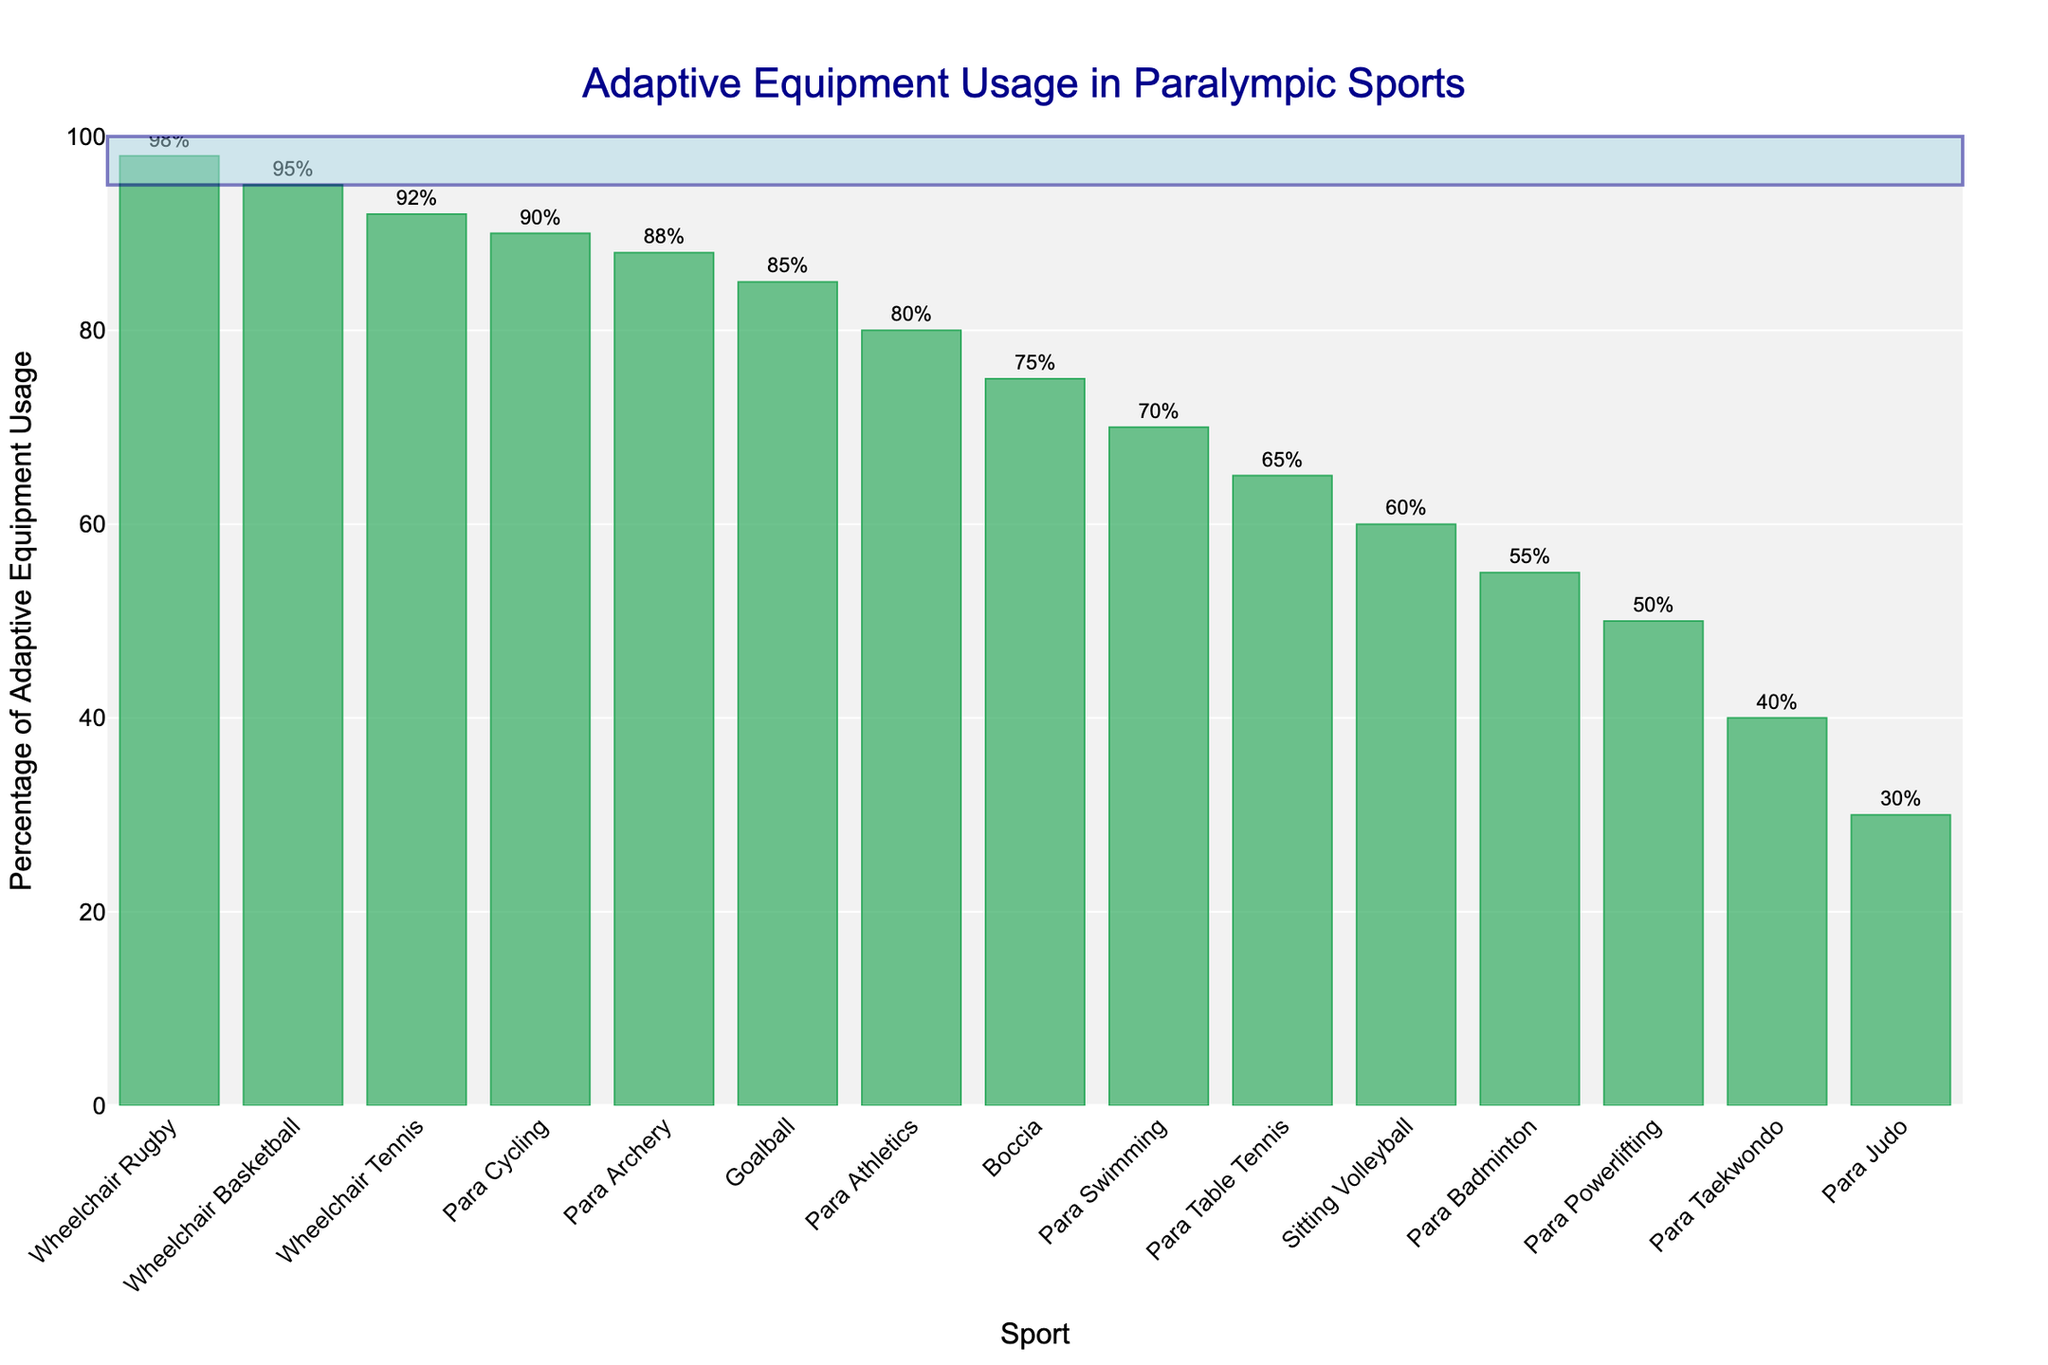Which sport has the highest percentage of adaptive equipment usage? To find the answer, look for the tallest bar in the chart. The title of the sport underneath this bar will indicate the sport with the highest usage.
Answer: Wheelchair Rugby Which sport has the lowest percentage of adaptive equipment usage? To determine this, identify the shortest bar in the chart and check the label of that sport.
Answer: Para Judo What is the difference in adaptive equipment usage between Para Judo and Wheelchair Rugby? First, note the percentage values for both sports from the corresponding bars. Then, subtract the percentage of Para Judo from that of Wheelchair Rugby (98% - 30%).
Answer: 68% Which sport has a higher percentage of adaptive equipment usage: Para Archery or Para Swimming? Compare the bars of both sports to see which one is taller. The taller bar indicates the higher usage.
Answer: Para Archery Among Para Cycling, Wheelchair Tennis, and Para Table Tennis, which sport has the lowest adaptive equipment usage? Examine the heights of the bars for these three sports. The shortest bar among them will indicate the sport with the lowest usage.
Answer: Para Table Tennis What is the median value of adaptive equipment usage for all the sports listed? To find the median, first list all the percentage values in ascending order: 30, 40, 50, 55, 60, 65, 70, 75, 80, 85, 88, 90, 92, 95, 98. As there are 15 data points, the median is the 8th value.
Answer: 75% Is the percentage of adaptive equipment usage in Para Badminton more or less than the average usage across all sports? First, calculate the average by summing all percentages and dividing by the number of sports: (95+85+70+60+80+90+92+75+65+98+88+50+30+55+40)/15 = 71%. Compare this with the percentage for Para Badminton (55%).
Answer: Less Which two sports have the most similar percentage of adaptive equipment usage? Compare the bars for the closest heights and identify those sports. The percent difference between Para Table Tennis (65%) and Sitting Volleyball (60%) is the smallest.
Answer: Sitting Volleyball and Para Table Tennis How much higher is the adaptive equipment usage in Goalball compared to Para Powerlifting? Compare the percentages for both sports and subtract the smaller from the larger: 85% - 50%.
Answer: 35% What is the total percentage of adaptive equipment usage for the top three sports? Identify the three tallest bars and sum their percentages: Wheelchair Rugby (98%), Wheelchair Basketball (95%), and Wheelchair Tennis (92%). The total is 98 + 95 + 92.
Answer: 285 